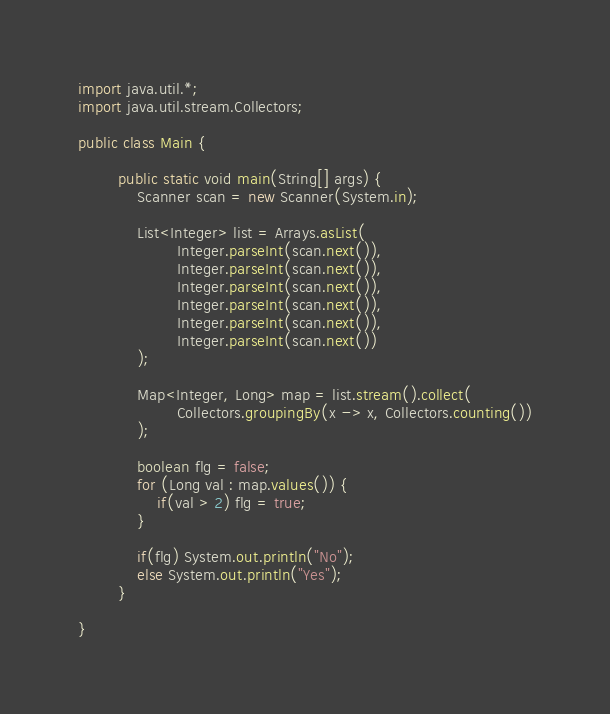<code> <loc_0><loc_0><loc_500><loc_500><_Java_>import java.util.*;
import java.util.stream.Collectors;

public class Main {

        public static void main(String[] args) {
            Scanner scan = new Scanner(System.in);

            List<Integer> list = Arrays.asList(
                    Integer.parseInt(scan.next()),
                    Integer.parseInt(scan.next()),
                    Integer.parseInt(scan.next()),
                    Integer.parseInt(scan.next()),
                    Integer.parseInt(scan.next()),
                    Integer.parseInt(scan.next())
            );

            Map<Integer, Long> map = list.stream().collect(
                    Collectors.groupingBy(x -> x, Collectors.counting())
            );

            boolean flg = false;
            for (Long val : map.values()) {
                if(val > 2) flg = true;
            }

            if(flg) System.out.println("No");
            else System.out.println("Yes");
        }

}</code> 